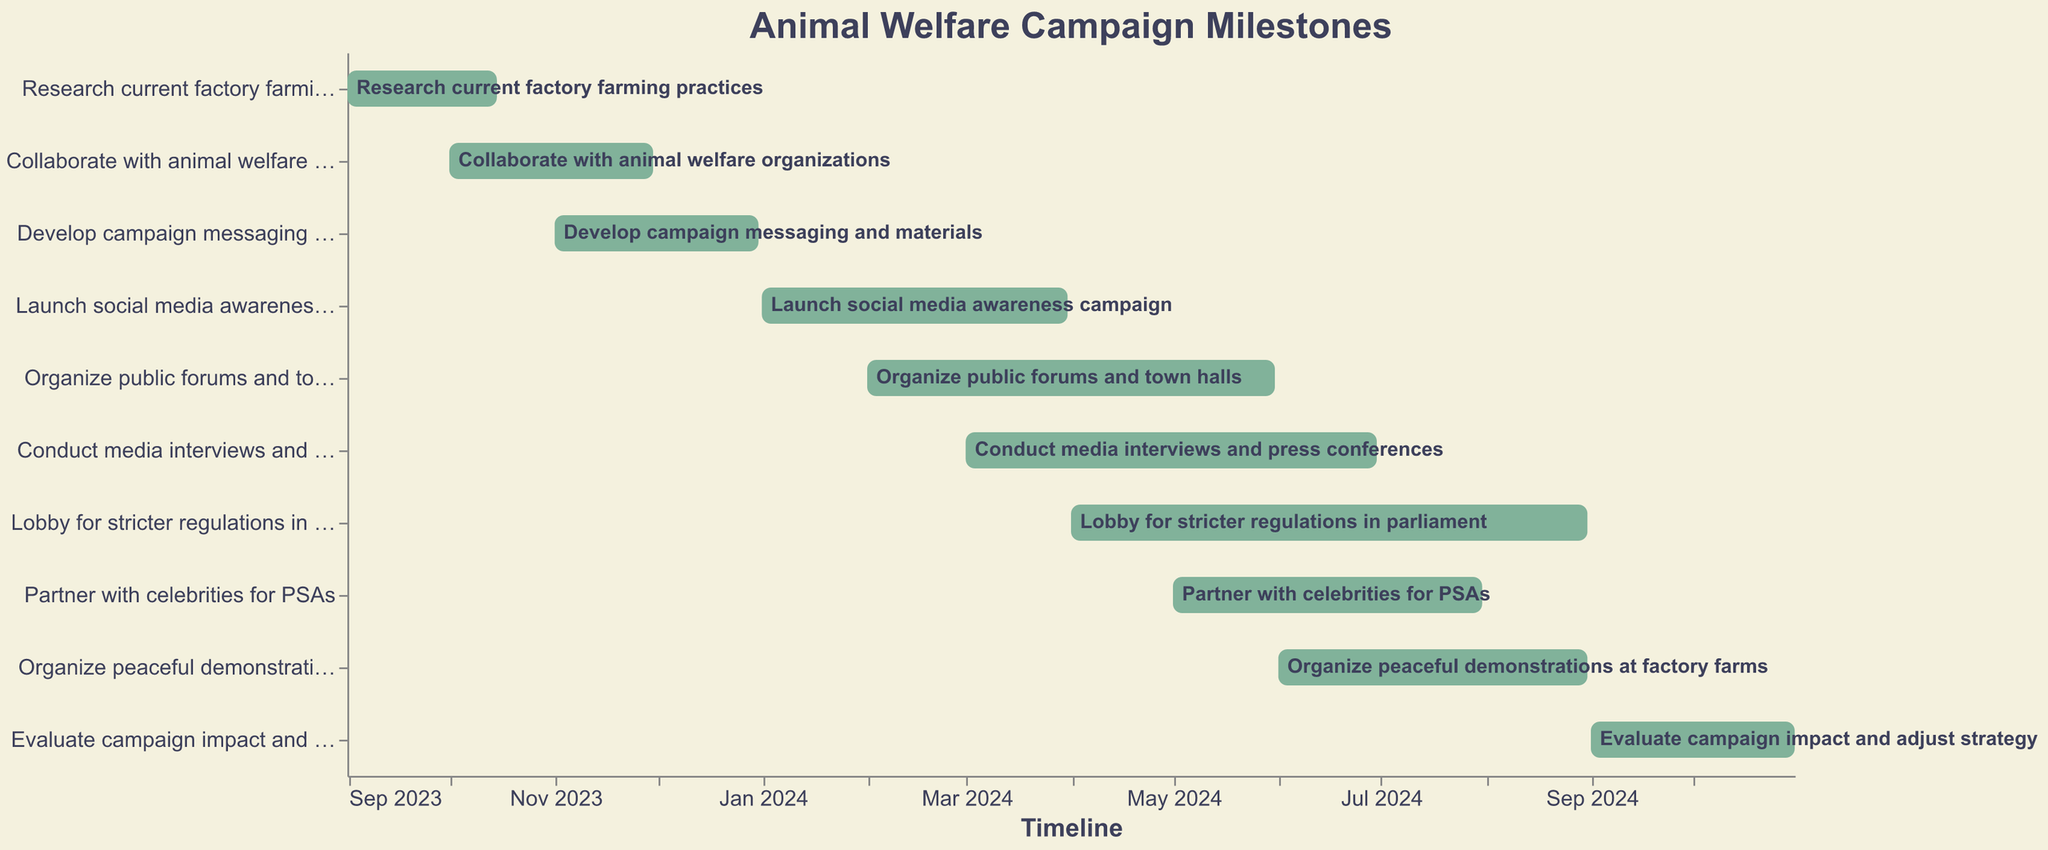How many tasks are displayed in the Gantt Chart? The figure shows each task represented by a bar. Counting these bars gives the total number of tasks.
Answer: 10 What is the title of the Gantt Chart? The title is usually displayed at the top of the chart. Here, it reads "Animal Welfare Campaign Milestones".
Answer: Animal Welfare Campaign Milestones Which task starts the earliest and ends the earliest? By examining the "Start Date" and "End Date" of each bar, we determine that "Research current factory farming practices" starts on 2023-09-01 and ends on 2023-10-15.
Answer: Research current factory farming practices During which two months does the task "Conduct media interviews and press conferences" occur? The start and end dates for this task are 2024-03-01 and 2024-06-30. Therefore, it spans from March 2024 to June 2024.
Answer: March and June 2024 Which task has the longest duration and what is that duration? By checking the length of each bar, we see that "Lobby for stricter regulations in parliament" starts on 2024-04-01 and ends on 2024-08-31. The duration is 5 months.
Answer: Lobby for stricter regulations in parliament, 5 months What's the timeline for "Organize public forums and town halls"? The "Start Date" and "End Date" for this task are 2024-02-01 and 2024-05-31 respectively, which can be read directly from the chart.
Answer: 2024-02-01 to 2024-05-31 Which tasks overlap with "Launch social media awareness campaign"? "Launch social media awareness campaign" occurs from 2024-01-01 to 2024-03-31. So, the overlapping tasks are "Organize public forums and town halls", "Conduct media interviews and press conferences".
Answer: Organize public forums and town halls, Conduct media interviews and press conferences What tasks are scheduled to start in May 2024? By checking the tasks and their corresponding "Start Date", "Partner with celebrities for PSAs" begins on 2024-05-01.
Answer: Partner with celebrities for PSAs When does the task "Evaluate campaign impact and adjust strategy" take place? According to its "Start Date" and "End Date", it happens from 2024-09-01 to 2024-10-31.
Answer: 2024-09-01 to 2024-10-31 